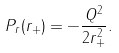<formula> <loc_0><loc_0><loc_500><loc_500>P _ { r } ( r _ { + } ) = - \frac { Q ^ { 2 } } { 2 r _ { + } ^ { 2 } } .</formula> 